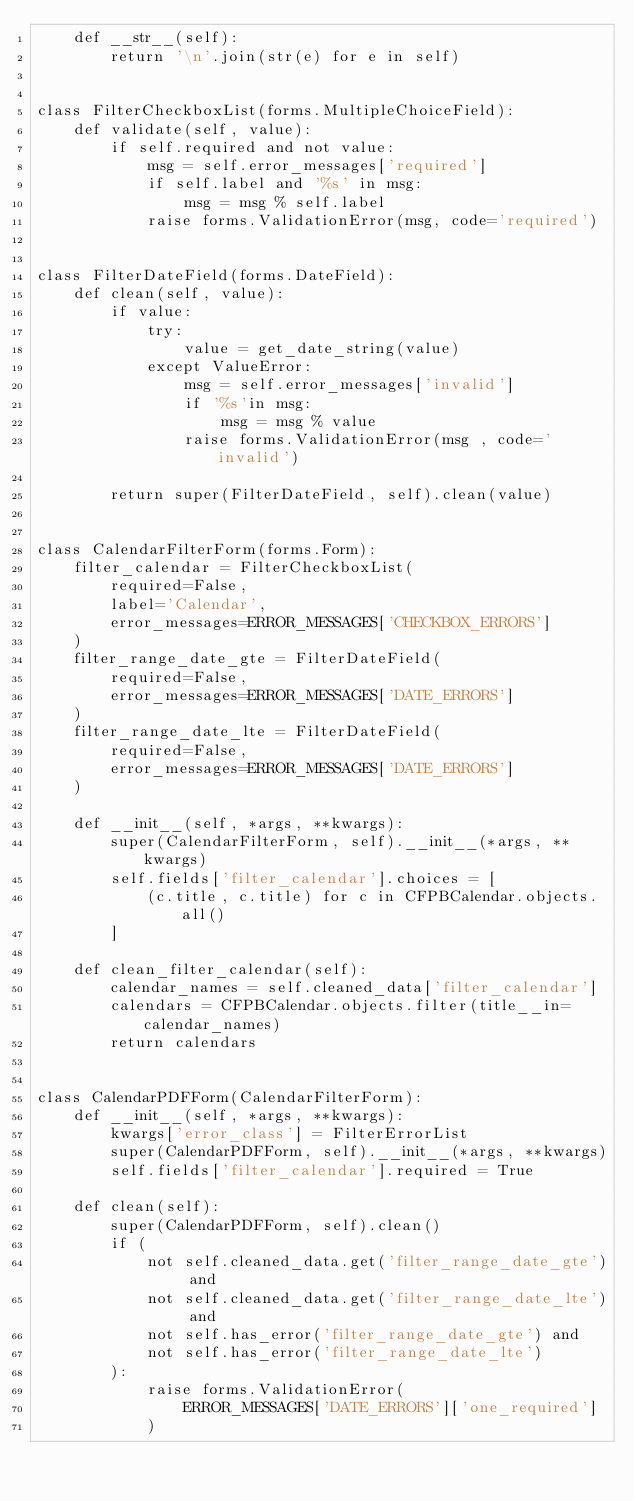<code> <loc_0><loc_0><loc_500><loc_500><_Python_>    def __str__(self):
        return '\n'.join(str(e) for e in self)


class FilterCheckboxList(forms.MultipleChoiceField):
    def validate(self, value):
        if self.required and not value:
            msg = self.error_messages['required']
            if self.label and '%s' in msg:
                msg = msg % self.label
            raise forms.ValidationError(msg, code='required')


class FilterDateField(forms.DateField):
    def clean(self, value):
        if value:
            try:
                value = get_date_string(value)
            except ValueError:
                msg = self.error_messages['invalid']
                if '%s'in msg:
                    msg = msg % value
                raise forms.ValidationError(msg , code='invalid')

        return super(FilterDateField, self).clean(value)


class CalendarFilterForm(forms.Form):
    filter_calendar = FilterCheckboxList(
        required=False,
        label='Calendar',
        error_messages=ERROR_MESSAGES['CHECKBOX_ERRORS']
    )
    filter_range_date_gte = FilterDateField(
        required=False,
        error_messages=ERROR_MESSAGES['DATE_ERRORS']
    )
    filter_range_date_lte = FilterDateField(
        required=False,
        error_messages=ERROR_MESSAGES['DATE_ERRORS']
    )

    def __init__(self, *args, **kwargs):
        super(CalendarFilterForm, self).__init__(*args, **kwargs)
        self.fields['filter_calendar'].choices = [
            (c.title, c.title) for c in CFPBCalendar.objects.all()
        ]

    def clean_filter_calendar(self):
        calendar_names = self.cleaned_data['filter_calendar']
        calendars = CFPBCalendar.objects.filter(title__in=calendar_names)
        return calendars


class CalendarPDFForm(CalendarFilterForm):
    def __init__(self, *args, **kwargs):
        kwargs['error_class'] = FilterErrorList
        super(CalendarPDFForm, self).__init__(*args, **kwargs)
        self.fields['filter_calendar'].required = True

    def clean(self):
        super(CalendarPDFForm, self).clean()
        if (
            not self.cleaned_data.get('filter_range_date_gte') and
            not self.cleaned_data.get('filter_range_date_lte') and
            not self.has_error('filter_range_date_gte') and
            not self.has_error('filter_range_date_lte')
        ):
            raise forms.ValidationError(
                ERROR_MESSAGES['DATE_ERRORS']['one_required']
            )
</code> 